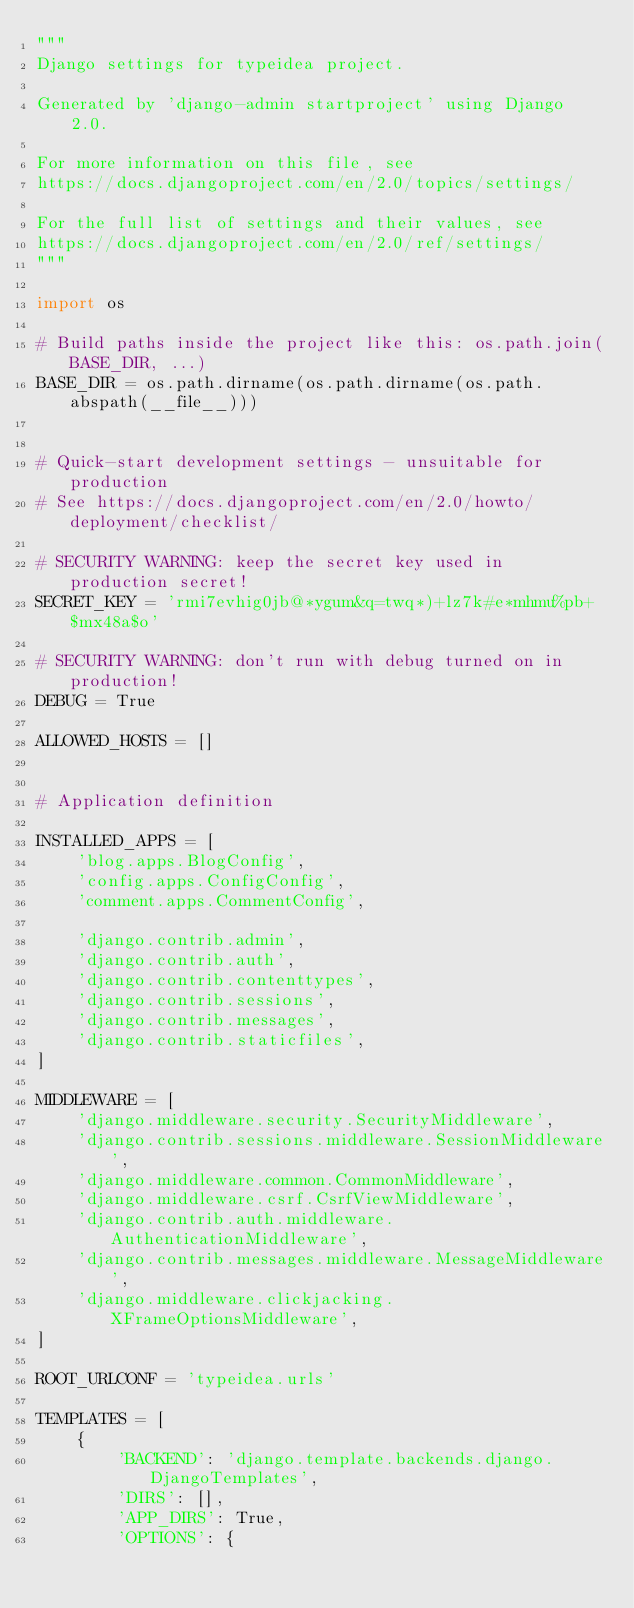<code> <loc_0><loc_0><loc_500><loc_500><_Python_>"""
Django settings for typeidea project.

Generated by 'django-admin startproject' using Django 2.0.

For more information on this file, see
https://docs.djangoproject.com/en/2.0/topics/settings/

For the full list of settings and their values, see
https://docs.djangoproject.com/en/2.0/ref/settings/
"""

import os

# Build paths inside the project like this: os.path.join(BASE_DIR, ...)
BASE_DIR = os.path.dirname(os.path.dirname(os.path.abspath(__file__)))


# Quick-start development settings - unsuitable for production
# See https://docs.djangoproject.com/en/2.0/howto/deployment/checklist/

# SECURITY WARNING: keep the secret key used in production secret!
SECRET_KEY = 'rmi7evhig0jb@*ygum&q=twq*)+lz7k#e*mhmu%pb+$mx48a$o'

# SECURITY WARNING: don't run with debug turned on in production!
DEBUG = True

ALLOWED_HOSTS = []


# Application definition

INSTALLED_APPS = [
    'blog.apps.BlogConfig',
    'config.apps.ConfigConfig',
    'comment.apps.CommentConfig',

    'django.contrib.admin',
    'django.contrib.auth',
    'django.contrib.contenttypes',
    'django.contrib.sessions',
    'django.contrib.messages',
    'django.contrib.staticfiles',
]

MIDDLEWARE = [
    'django.middleware.security.SecurityMiddleware',
    'django.contrib.sessions.middleware.SessionMiddleware',
    'django.middleware.common.CommonMiddleware',
    'django.middleware.csrf.CsrfViewMiddleware',
    'django.contrib.auth.middleware.AuthenticationMiddleware',
    'django.contrib.messages.middleware.MessageMiddleware',
    'django.middleware.clickjacking.XFrameOptionsMiddleware',
]

ROOT_URLCONF = 'typeidea.urls'

TEMPLATES = [
    {
        'BACKEND': 'django.template.backends.django.DjangoTemplates',
        'DIRS': [],
        'APP_DIRS': True,
        'OPTIONS': {</code> 